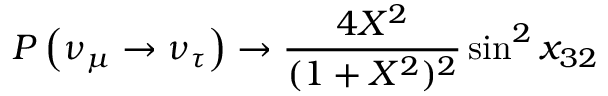<formula> <loc_0><loc_0><loc_500><loc_500>P \left ( \nu _ { \mu } \rightarrow \nu _ { \tau } \right ) \rightarrow \frac { 4 X ^ { 2 } } { ( 1 + X ^ { 2 } ) ^ { 2 } } \sin ^ { 2 } x _ { 3 2 }</formula> 